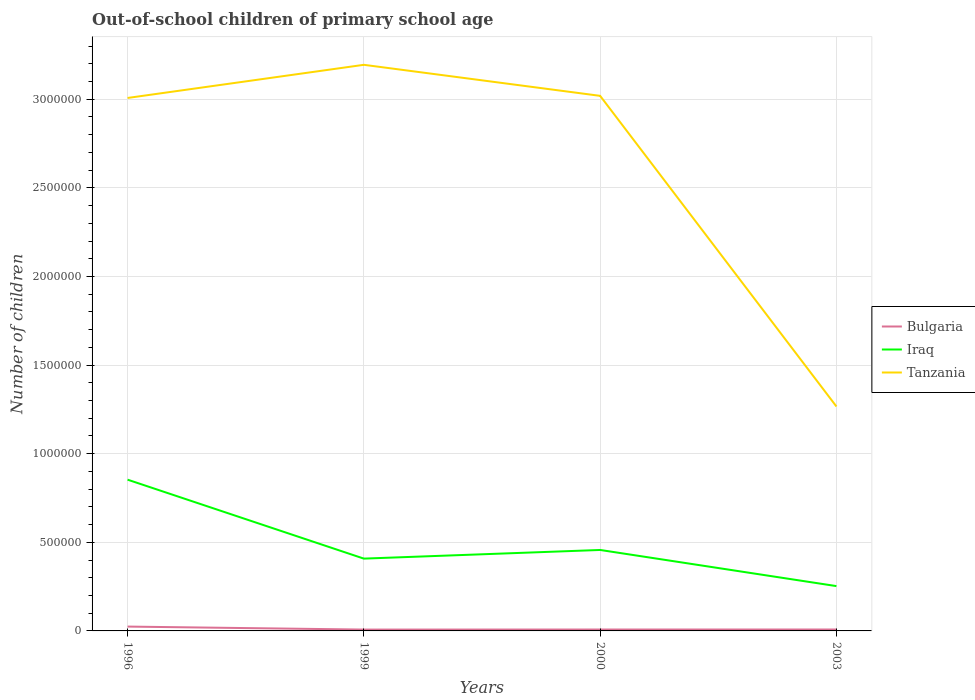How many different coloured lines are there?
Give a very brief answer. 3. Is the number of lines equal to the number of legend labels?
Offer a very short reply. Yes. Across all years, what is the maximum number of out-of-school children in Bulgaria?
Ensure brevity in your answer.  7612. In which year was the number of out-of-school children in Iraq maximum?
Give a very brief answer. 2003. What is the total number of out-of-school children in Bulgaria in the graph?
Keep it short and to the point. -445. What is the difference between the highest and the second highest number of out-of-school children in Bulgaria?
Give a very brief answer. 1.69e+04. Is the number of out-of-school children in Iraq strictly greater than the number of out-of-school children in Bulgaria over the years?
Your response must be concise. No. What is the difference between two consecutive major ticks on the Y-axis?
Ensure brevity in your answer.  5.00e+05. Are the values on the major ticks of Y-axis written in scientific E-notation?
Provide a short and direct response. No. Does the graph contain any zero values?
Provide a succinct answer. No. Does the graph contain grids?
Make the answer very short. Yes. Where does the legend appear in the graph?
Give a very brief answer. Center right. How are the legend labels stacked?
Your answer should be compact. Vertical. What is the title of the graph?
Keep it short and to the point. Out-of-school children of primary school age. Does "Macao" appear as one of the legend labels in the graph?
Keep it short and to the point. No. What is the label or title of the Y-axis?
Give a very brief answer. Number of children. What is the Number of children in Bulgaria in 1996?
Your answer should be compact. 2.45e+04. What is the Number of children in Iraq in 1996?
Your response must be concise. 8.53e+05. What is the Number of children of Tanzania in 1996?
Your answer should be compact. 3.01e+06. What is the Number of children in Bulgaria in 1999?
Your response must be concise. 7612. What is the Number of children of Iraq in 1999?
Provide a succinct answer. 4.08e+05. What is the Number of children of Tanzania in 1999?
Your answer should be very brief. 3.19e+06. What is the Number of children of Bulgaria in 2000?
Offer a very short reply. 7892. What is the Number of children in Iraq in 2000?
Give a very brief answer. 4.57e+05. What is the Number of children in Tanzania in 2000?
Keep it short and to the point. 3.02e+06. What is the Number of children in Bulgaria in 2003?
Your response must be concise. 8057. What is the Number of children of Iraq in 2003?
Ensure brevity in your answer.  2.53e+05. What is the Number of children of Tanzania in 2003?
Give a very brief answer. 1.27e+06. Across all years, what is the maximum Number of children of Bulgaria?
Your answer should be compact. 2.45e+04. Across all years, what is the maximum Number of children in Iraq?
Offer a very short reply. 8.53e+05. Across all years, what is the maximum Number of children of Tanzania?
Your answer should be compact. 3.19e+06. Across all years, what is the minimum Number of children of Bulgaria?
Offer a terse response. 7612. Across all years, what is the minimum Number of children of Iraq?
Offer a terse response. 2.53e+05. Across all years, what is the minimum Number of children in Tanzania?
Offer a terse response. 1.27e+06. What is the total Number of children in Bulgaria in the graph?
Give a very brief answer. 4.81e+04. What is the total Number of children of Iraq in the graph?
Your answer should be very brief. 1.97e+06. What is the total Number of children of Tanzania in the graph?
Keep it short and to the point. 1.05e+07. What is the difference between the Number of children in Bulgaria in 1996 and that in 1999?
Ensure brevity in your answer.  1.69e+04. What is the difference between the Number of children in Iraq in 1996 and that in 1999?
Your answer should be very brief. 4.46e+05. What is the difference between the Number of children in Tanzania in 1996 and that in 1999?
Offer a terse response. -1.87e+05. What is the difference between the Number of children of Bulgaria in 1996 and that in 2000?
Make the answer very short. 1.66e+04. What is the difference between the Number of children of Iraq in 1996 and that in 2000?
Give a very brief answer. 3.97e+05. What is the difference between the Number of children in Tanzania in 1996 and that in 2000?
Your answer should be compact. -1.20e+04. What is the difference between the Number of children of Bulgaria in 1996 and that in 2003?
Your response must be concise. 1.65e+04. What is the difference between the Number of children in Iraq in 1996 and that in 2003?
Your response must be concise. 6.01e+05. What is the difference between the Number of children of Tanzania in 1996 and that in 2003?
Offer a very short reply. 1.74e+06. What is the difference between the Number of children of Bulgaria in 1999 and that in 2000?
Your response must be concise. -280. What is the difference between the Number of children in Iraq in 1999 and that in 2000?
Provide a succinct answer. -4.88e+04. What is the difference between the Number of children of Tanzania in 1999 and that in 2000?
Make the answer very short. 1.75e+05. What is the difference between the Number of children in Bulgaria in 1999 and that in 2003?
Provide a short and direct response. -445. What is the difference between the Number of children of Iraq in 1999 and that in 2003?
Offer a terse response. 1.55e+05. What is the difference between the Number of children in Tanzania in 1999 and that in 2003?
Your response must be concise. 1.93e+06. What is the difference between the Number of children in Bulgaria in 2000 and that in 2003?
Your answer should be very brief. -165. What is the difference between the Number of children in Iraq in 2000 and that in 2003?
Ensure brevity in your answer.  2.04e+05. What is the difference between the Number of children in Tanzania in 2000 and that in 2003?
Offer a very short reply. 1.75e+06. What is the difference between the Number of children in Bulgaria in 1996 and the Number of children in Iraq in 1999?
Make the answer very short. -3.83e+05. What is the difference between the Number of children of Bulgaria in 1996 and the Number of children of Tanzania in 1999?
Offer a terse response. -3.17e+06. What is the difference between the Number of children in Iraq in 1996 and the Number of children in Tanzania in 1999?
Your answer should be compact. -2.34e+06. What is the difference between the Number of children in Bulgaria in 1996 and the Number of children in Iraq in 2000?
Your response must be concise. -4.32e+05. What is the difference between the Number of children of Bulgaria in 1996 and the Number of children of Tanzania in 2000?
Make the answer very short. -2.99e+06. What is the difference between the Number of children of Iraq in 1996 and the Number of children of Tanzania in 2000?
Your response must be concise. -2.17e+06. What is the difference between the Number of children of Bulgaria in 1996 and the Number of children of Iraq in 2003?
Your answer should be very brief. -2.28e+05. What is the difference between the Number of children of Bulgaria in 1996 and the Number of children of Tanzania in 2003?
Your answer should be very brief. -1.24e+06. What is the difference between the Number of children in Iraq in 1996 and the Number of children in Tanzania in 2003?
Provide a short and direct response. -4.13e+05. What is the difference between the Number of children of Bulgaria in 1999 and the Number of children of Iraq in 2000?
Your response must be concise. -4.49e+05. What is the difference between the Number of children in Bulgaria in 1999 and the Number of children in Tanzania in 2000?
Make the answer very short. -3.01e+06. What is the difference between the Number of children in Iraq in 1999 and the Number of children in Tanzania in 2000?
Your answer should be compact. -2.61e+06. What is the difference between the Number of children in Bulgaria in 1999 and the Number of children in Iraq in 2003?
Your answer should be compact. -2.45e+05. What is the difference between the Number of children in Bulgaria in 1999 and the Number of children in Tanzania in 2003?
Keep it short and to the point. -1.26e+06. What is the difference between the Number of children in Iraq in 1999 and the Number of children in Tanzania in 2003?
Provide a succinct answer. -8.58e+05. What is the difference between the Number of children of Bulgaria in 2000 and the Number of children of Iraq in 2003?
Give a very brief answer. -2.45e+05. What is the difference between the Number of children of Bulgaria in 2000 and the Number of children of Tanzania in 2003?
Provide a short and direct response. -1.26e+06. What is the difference between the Number of children of Iraq in 2000 and the Number of children of Tanzania in 2003?
Make the answer very short. -8.10e+05. What is the average Number of children in Bulgaria per year?
Make the answer very short. 1.20e+04. What is the average Number of children of Iraq per year?
Provide a short and direct response. 4.93e+05. What is the average Number of children in Tanzania per year?
Offer a terse response. 2.62e+06. In the year 1996, what is the difference between the Number of children in Bulgaria and Number of children in Iraq?
Your answer should be very brief. -8.29e+05. In the year 1996, what is the difference between the Number of children in Bulgaria and Number of children in Tanzania?
Your answer should be very brief. -2.98e+06. In the year 1996, what is the difference between the Number of children in Iraq and Number of children in Tanzania?
Your answer should be compact. -2.15e+06. In the year 1999, what is the difference between the Number of children in Bulgaria and Number of children in Iraq?
Offer a very short reply. -4.00e+05. In the year 1999, what is the difference between the Number of children of Bulgaria and Number of children of Tanzania?
Give a very brief answer. -3.19e+06. In the year 1999, what is the difference between the Number of children in Iraq and Number of children in Tanzania?
Keep it short and to the point. -2.79e+06. In the year 2000, what is the difference between the Number of children of Bulgaria and Number of children of Iraq?
Your answer should be very brief. -4.49e+05. In the year 2000, what is the difference between the Number of children of Bulgaria and Number of children of Tanzania?
Ensure brevity in your answer.  -3.01e+06. In the year 2000, what is the difference between the Number of children of Iraq and Number of children of Tanzania?
Your answer should be very brief. -2.56e+06. In the year 2003, what is the difference between the Number of children of Bulgaria and Number of children of Iraq?
Provide a succinct answer. -2.45e+05. In the year 2003, what is the difference between the Number of children in Bulgaria and Number of children in Tanzania?
Give a very brief answer. -1.26e+06. In the year 2003, what is the difference between the Number of children of Iraq and Number of children of Tanzania?
Your answer should be compact. -1.01e+06. What is the ratio of the Number of children in Bulgaria in 1996 to that in 1999?
Your answer should be compact. 3.22. What is the ratio of the Number of children in Iraq in 1996 to that in 1999?
Your response must be concise. 2.09. What is the ratio of the Number of children in Tanzania in 1996 to that in 1999?
Offer a very short reply. 0.94. What is the ratio of the Number of children in Bulgaria in 1996 to that in 2000?
Your response must be concise. 3.11. What is the ratio of the Number of children in Iraq in 1996 to that in 2000?
Your answer should be compact. 1.87. What is the ratio of the Number of children of Tanzania in 1996 to that in 2000?
Your response must be concise. 1. What is the ratio of the Number of children of Bulgaria in 1996 to that in 2003?
Offer a very short reply. 3.04. What is the ratio of the Number of children of Iraq in 1996 to that in 2003?
Provide a succinct answer. 3.37. What is the ratio of the Number of children in Tanzania in 1996 to that in 2003?
Ensure brevity in your answer.  2.37. What is the ratio of the Number of children in Bulgaria in 1999 to that in 2000?
Give a very brief answer. 0.96. What is the ratio of the Number of children of Iraq in 1999 to that in 2000?
Provide a short and direct response. 0.89. What is the ratio of the Number of children of Tanzania in 1999 to that in 2000?
Offer a terse response. 1.06. What is the ratio of the Number of children in Bulgaria in 1999 to that in 2003?
Provide a short and direct response. 0.94. What is the ratio of the Number of children of Iraq in 1999 to that in 2003?
Ensure brevity in your answer.  1.61. What is the ratio of the Number of children in Tanzania in 1999 to that in 2003?
Offer a terse response. 2.52. What is the ratio of the Number of children of Bulgaria in 2000 to that in 2003?
Offer a very short reply. 0.98. What is the ratio of the Number of children in Iraq in 2000 to that in 2003?
Provide a short and direct response. 1.81. What is the ratio of the Number of children in Tanzania in 2000 to that in 2003?
Offer a terse response. 2.38. What is the difference between the highest and the second highest Number of children in Bulgaria?
Offer a terse response. 1.65e+04. What is the difference between the highest and the second highest Number of children in Iraq?
Ensure brevity in your answer.  3.97e+05. What is the difference between the highest and the second highest Number of children in Tanzania?
Your answer should be very brief. 1.75e+05. What is the difference between the highest and the lowest Number of children of Bulgaria?
Your response must be concise. 1.69e+04. What is the difference between the highest and the lowest Number of children in Iraq?
Provide a succinct answer. 6.01e+05. What is the difference between the highest and the lowest Number of children of Tanzania?
Offer a very short reply. 1.93e+06. 